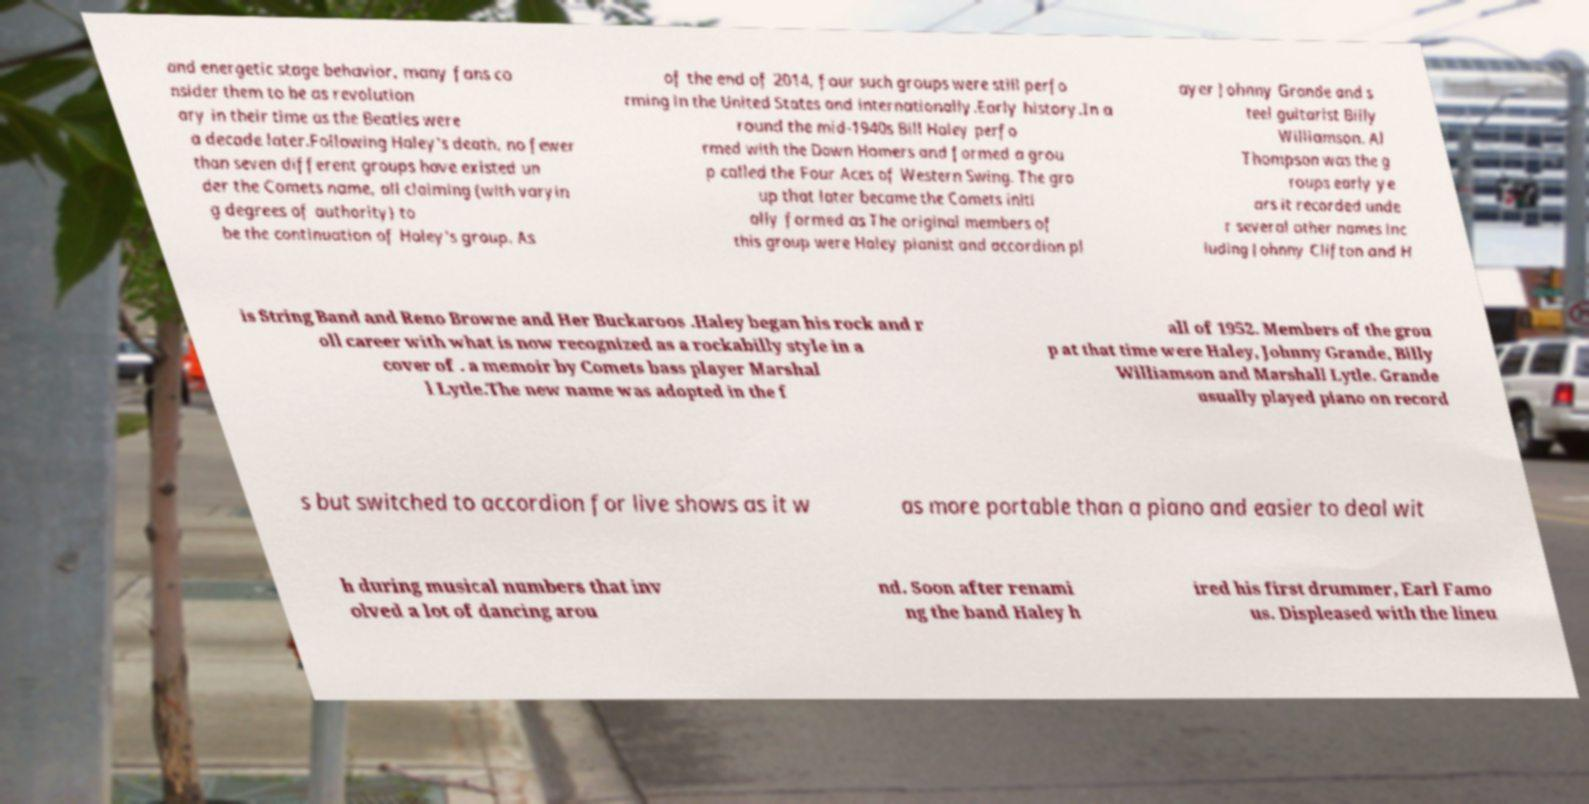There's text embedded in this image that I need extracted. Can you transcribe it verbatim? and energetic stage behavior, many fans co nsider them to be as revolution ary in their time as the Beatles were a decade later.Following Haley's death, no fewer than seven different groups have existed un der the Comets name, all claiming (with varyin g degrees of authority) to be the continuation of Haley's group. As of the end of 2014, four such groups were still perfo rming in the United States and internationally.Early history.In a round the mid-1940s Bill Haley perfo rmed with the Down Homers and formed a grou p called the Four Aces of Western Swing. The gro up that later became the Comets initi ally formed as The original members of this group were Haley pianist and accordion pl ayer Johnny Grande and s teel guitarist Billy Williamson. Al Thompson was the g roups early ye ars it recorded unde r several other names inc luding Johnny Clifton and H is String Band and Reno Browne and Her Buckaroos .Haley began his rock and r oll career with what is now recognized as a rockabilly style in a cover of . a memoir by Comets bass player Marshal l Lytle.The new name was adopted in the f all of 1952. Members of the grou p at that time were Haley, Johnny Grande, Billy Williamson and Marshall Lytle. Grande usually played piano on record s but switched to accordion for live shows as it w as more portable than a piano and easier to deal wit h during musical numbers that inv olved a lot of dancing arou nd. Soon after renami ng the band Haley h ired his first drummer, Earl Famo us. Displeased with the lineu 